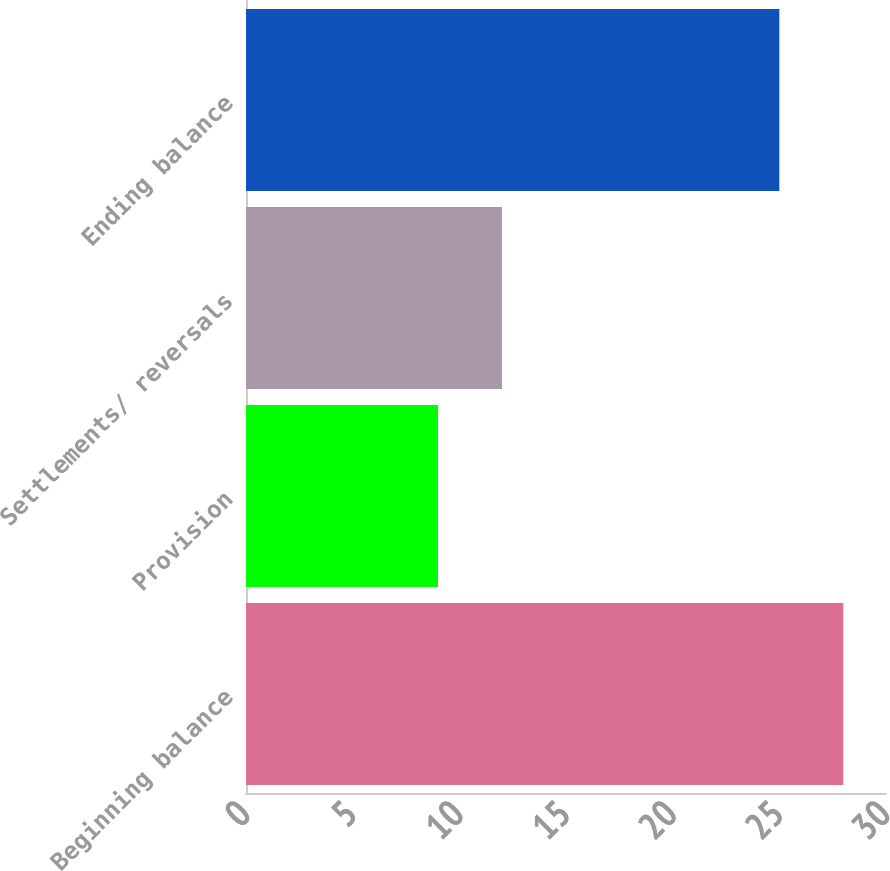<chart> <loc_0><loc_0><loc_500><loc_500><bar_chart><fcel>Beginning balance<fcel>Provision<fcel>Settlements/ reversals<fcel>Ending balance<nl><fcel>28<fcel>9<fcel>12<fcel>25<nl></chart> 